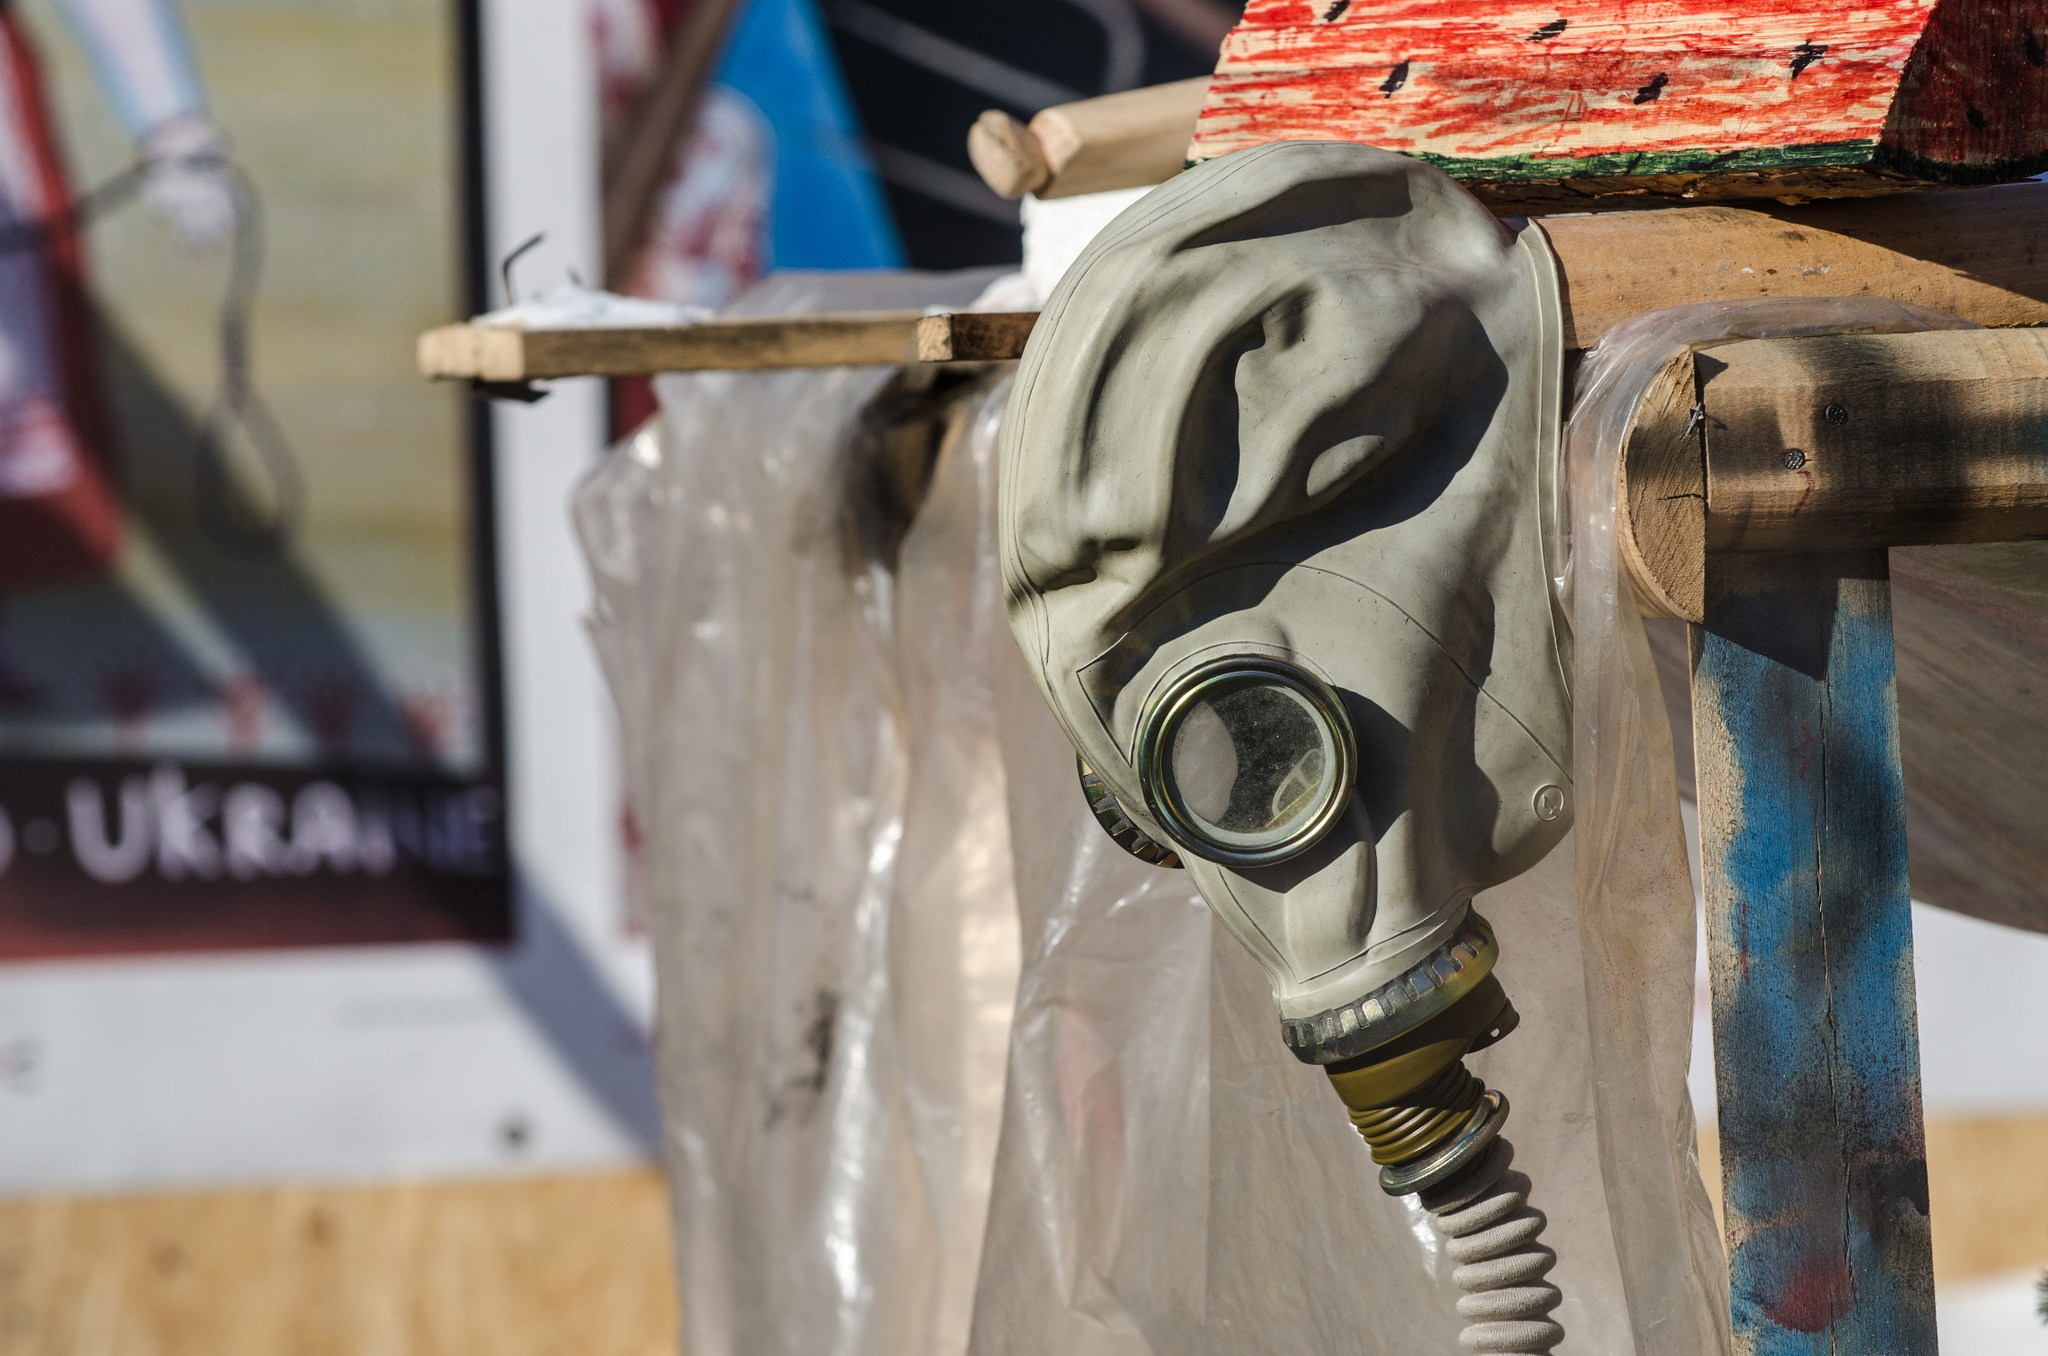How does the background poster contribute to the interpretation of this image? The background poster, featuring Cyrillic text and a Ukrainian flag, places the gas mask within a specific cultural and geographic context, suggesting a Ukrainian setting. This linkage may indicate that the gas mask is part of a larger narrative about Ukraine's historical or recent experiences with conflict and the nation's resilience. It could also be a commemorative installation, reflecting on the country's defense mechanisms against external threats. 